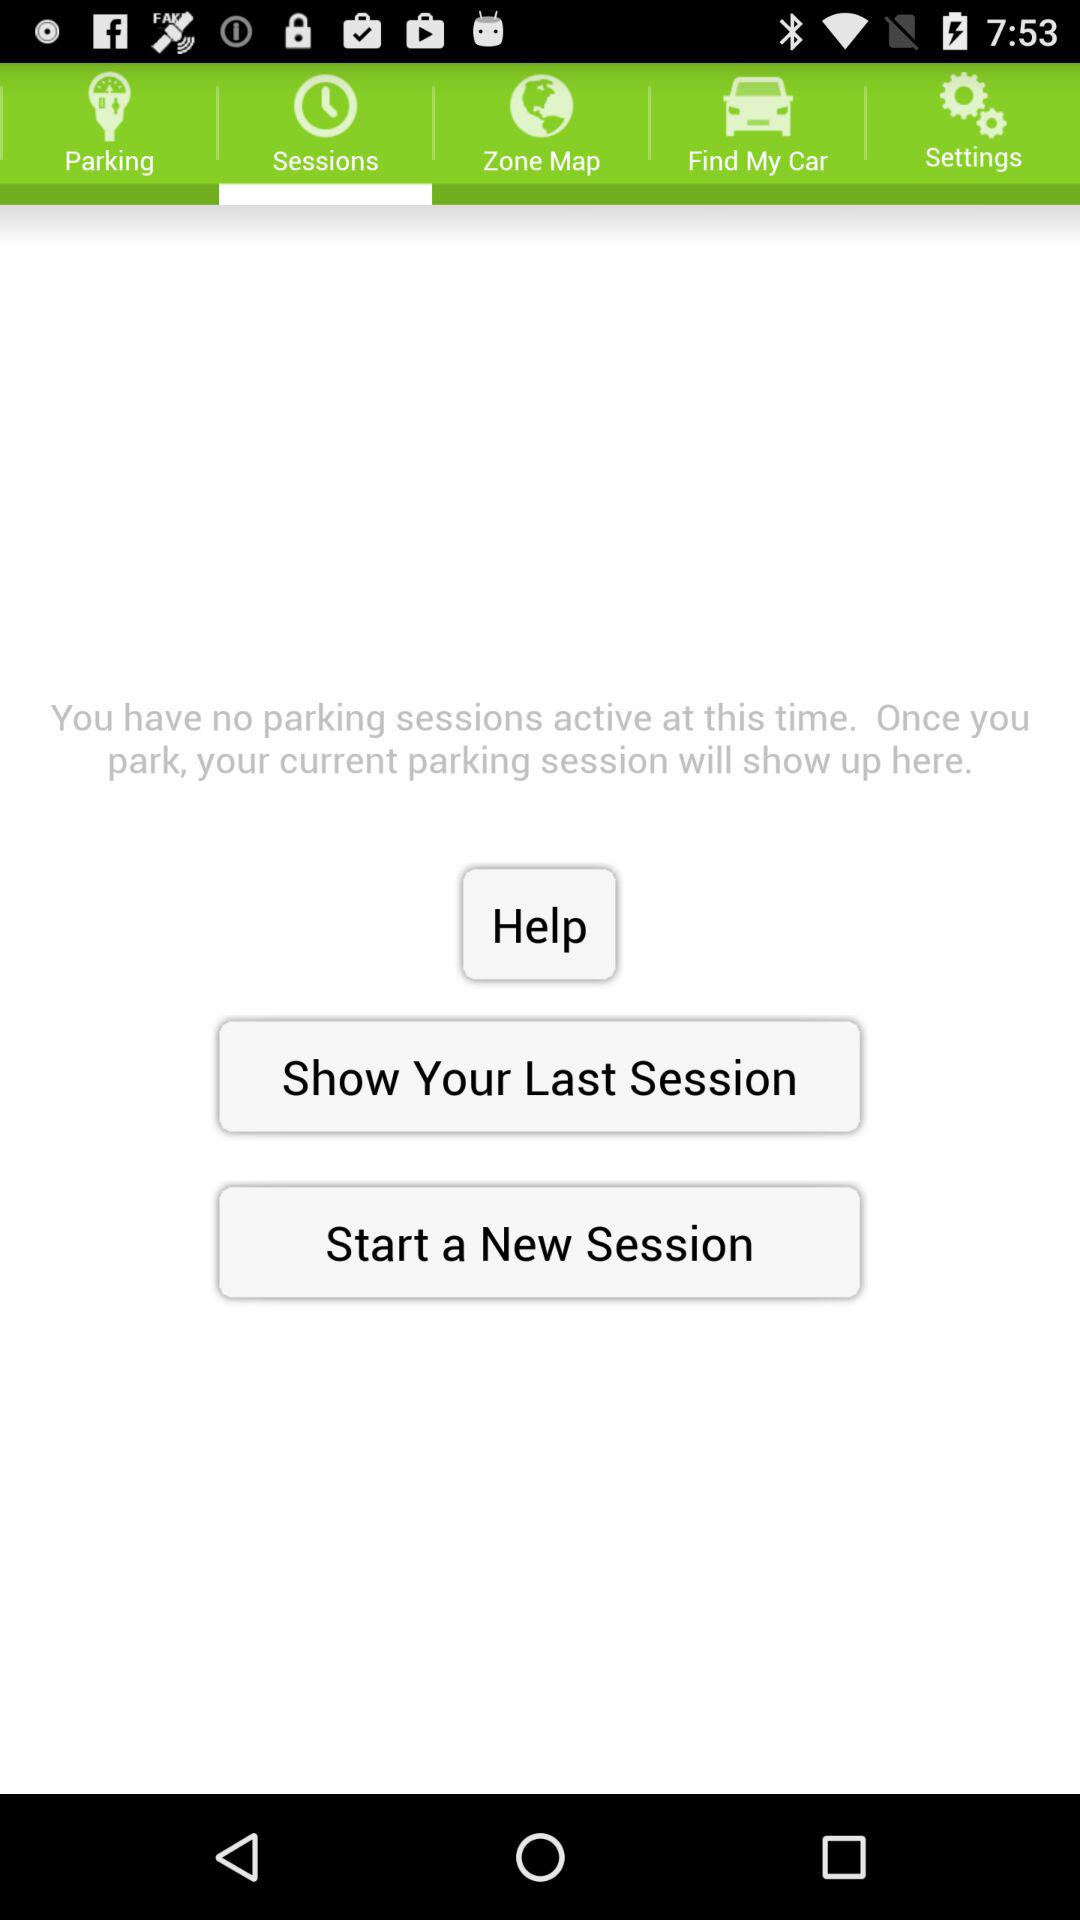How many sessions are currently active?
Answer the question using a single word or phrase. 0 